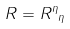<formula> <loc_0><loc_0><loc_500><loc_500>R = { R ^ { \eta } } _ { \eta }</formula> 